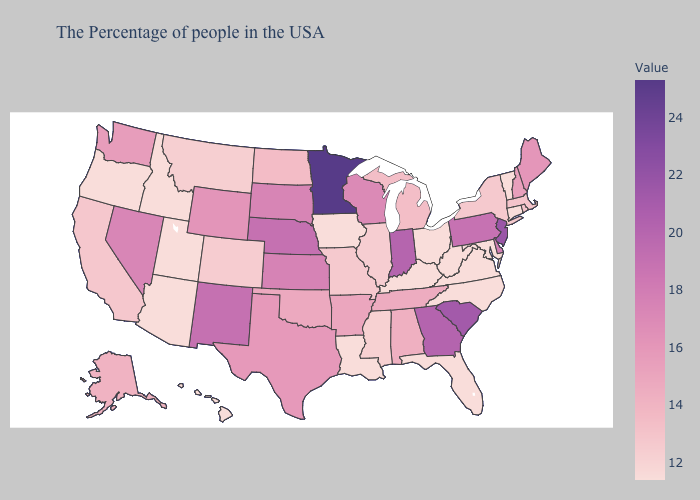Does the map have missing data?
Quick response, please. No. Does Mississippi have a higher value than Nevada?
Quick response, please. No. Among the states that border North Dakota , does Montana have the lowest value?
Short answer required. Yes. Does Virginia have the highest value in the USA?
Concise answer only. No. Does Washington have the lowest value in the West?
Give a very brief answer. No. 